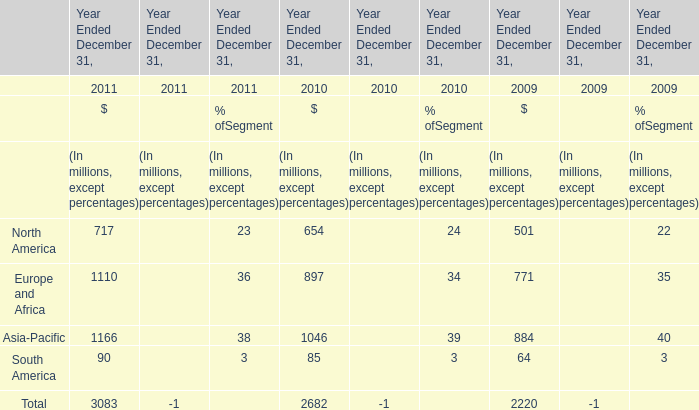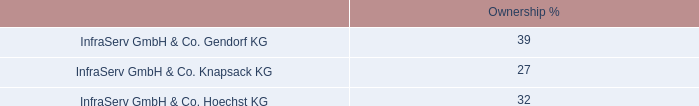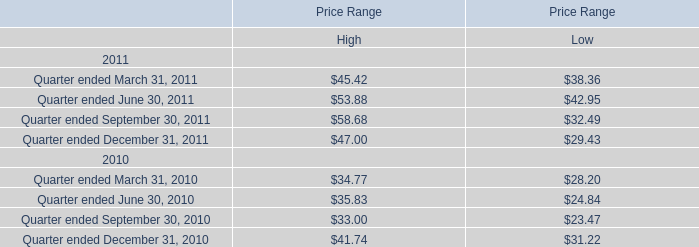what is the growth rate in cash dividends received in 2011 compare to 2010? 
Computations: ((78 - 71) / 71)
Answer: 0.09859. 